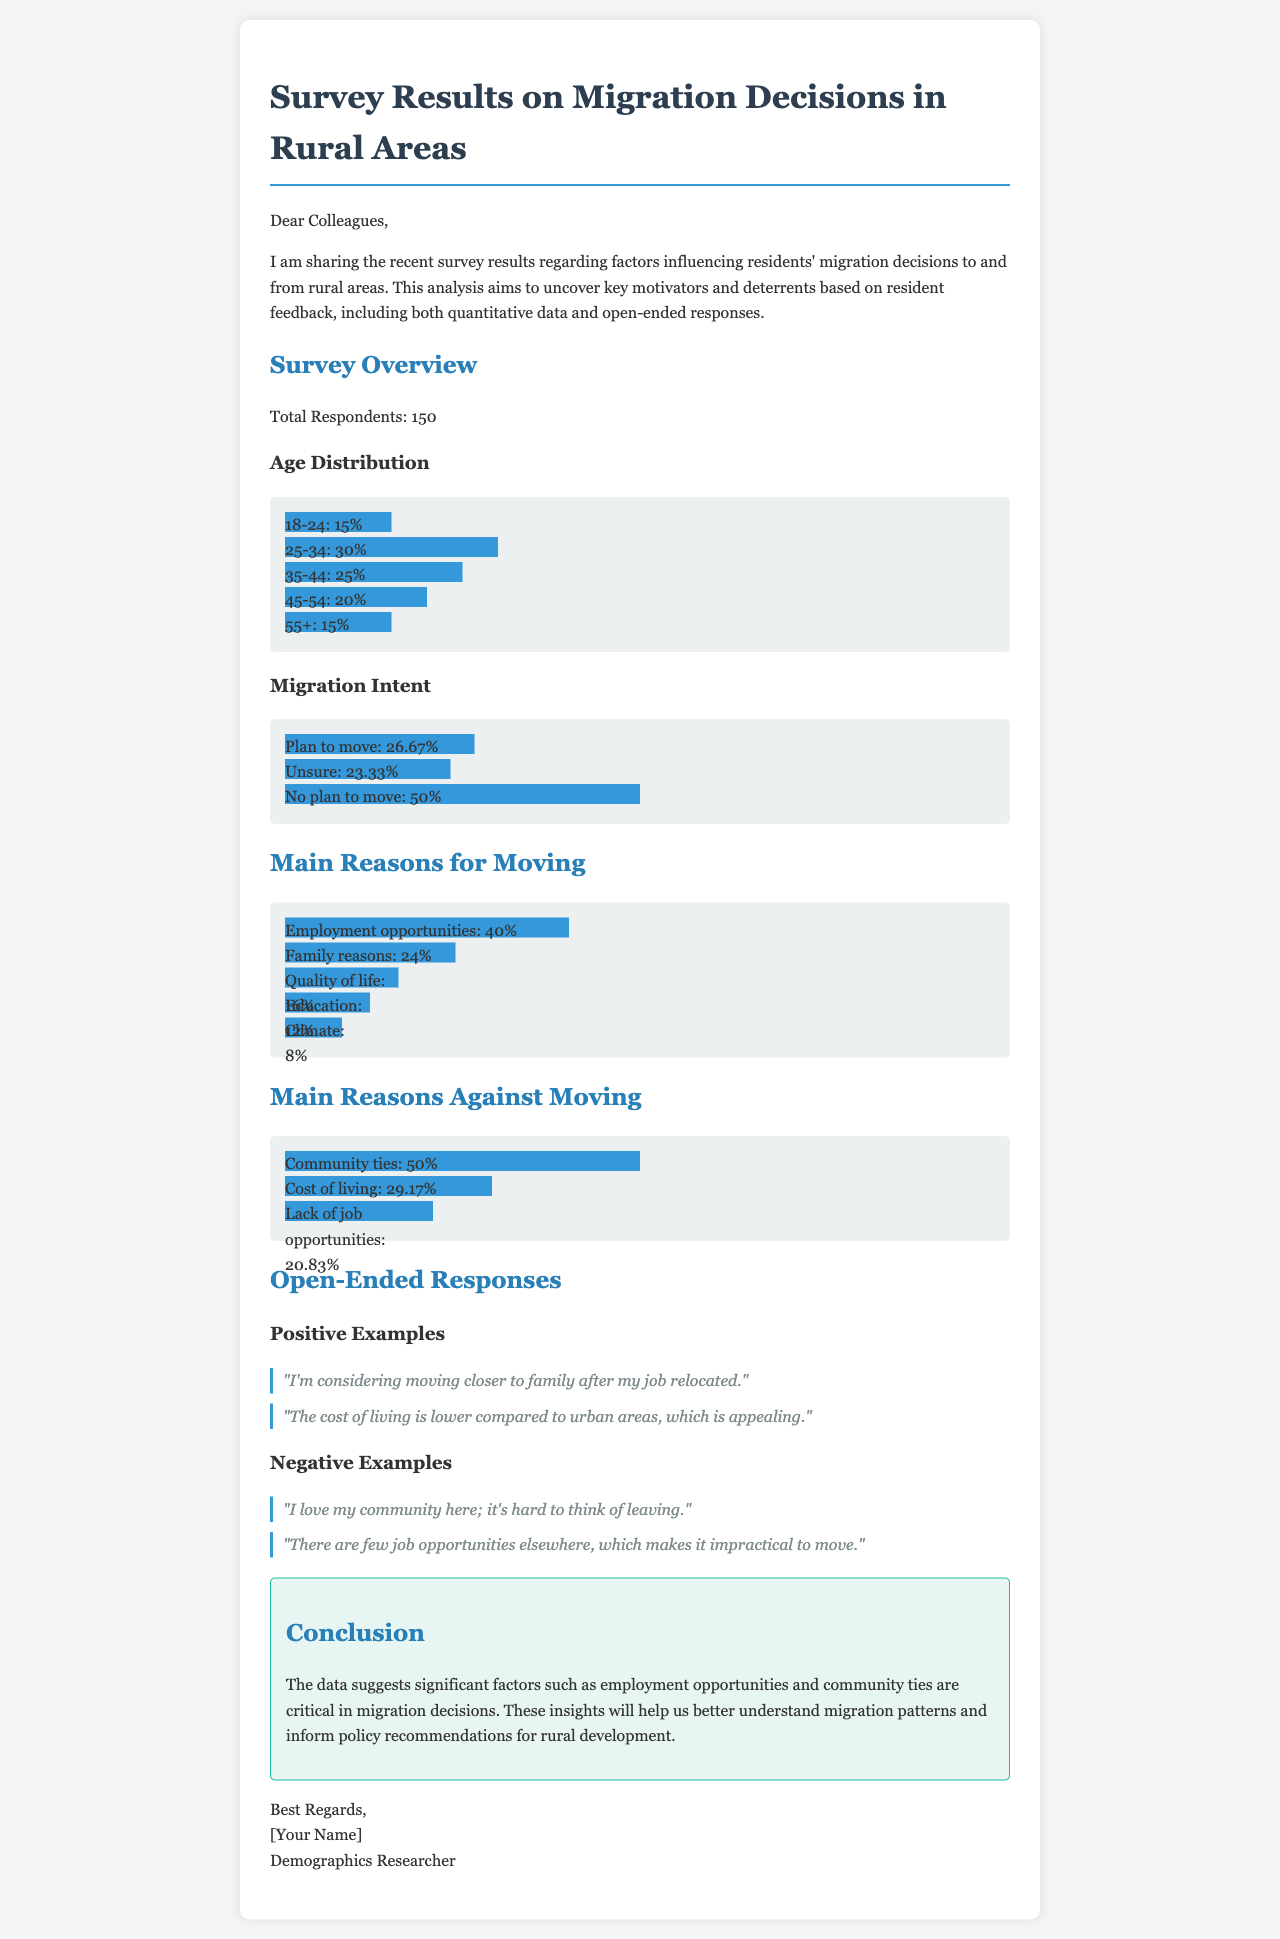What is the total number of respondents? The total number of respondents is indicated in the survey overview section of the document.
Answer: 150 What percentage of respondents plan to move? The percentage of respondents planning to move can be found in the migration intent chart.
Answer: 26.67% What is the main reason for moving according to the respondents? The main reason for moving is the factor that has the highest percentage in the "Main Reasons for Moving" chart.
Answer: Employment opportunities What percentage of respondents cited community ties as a reason against moving? The percentage citing community ties can be found in the "Main Reasons Against Moving" chart.
Answer: 50% What is one of the positive open-ended responses mentioned? A positive open-ended response is a quote listed in the open-ended responses section.
Answer: "I'm considering moving closer to family after my job relocated." What age group has the highest percentage of respondents? The age group with the highest percentage can be found in the "Age Distribution" chart.
Answer: 25-34 How many respondents are unsure about their migration plans? The number of respondents unsure about their migration plans is derived from the percentage in the "Migration Intent" chart.
Answer: 23.33% Which reason for moving has the lowest percentage? The reason for moving with the lowest percentage is indicated in the "Main Reasons for Moving" chart.
Answer: Climate What is the overall conclusion of the survey analysis? The conclusion summarizes the key findings regarding migration decisions from the data presented in the document.
Answer: Employment opportunities and community ties are critical 